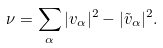Convert formula to latex. <formula><loc_0><loc_0><loc_500><loc_500>\nu = \sum _ { \alpha } | v _ { \alpha } | ^ { 2 } - | \tilde { v } _ { \alpha } | ^ { 2 } .</formula> 